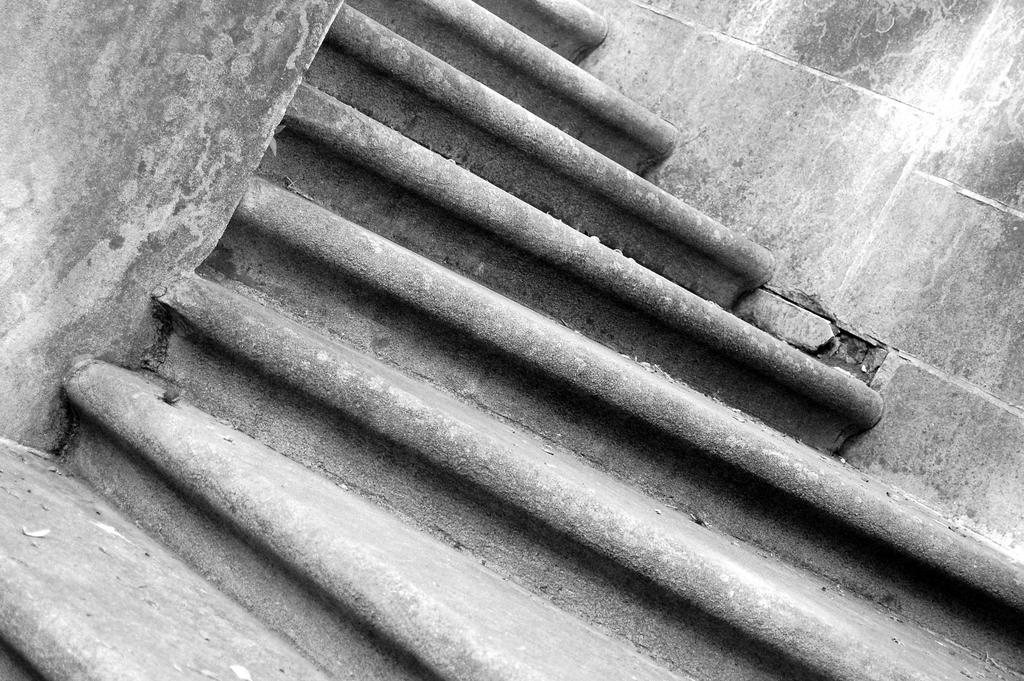Can you describe this image briefly? There are stairs in the foreground area of the image. 